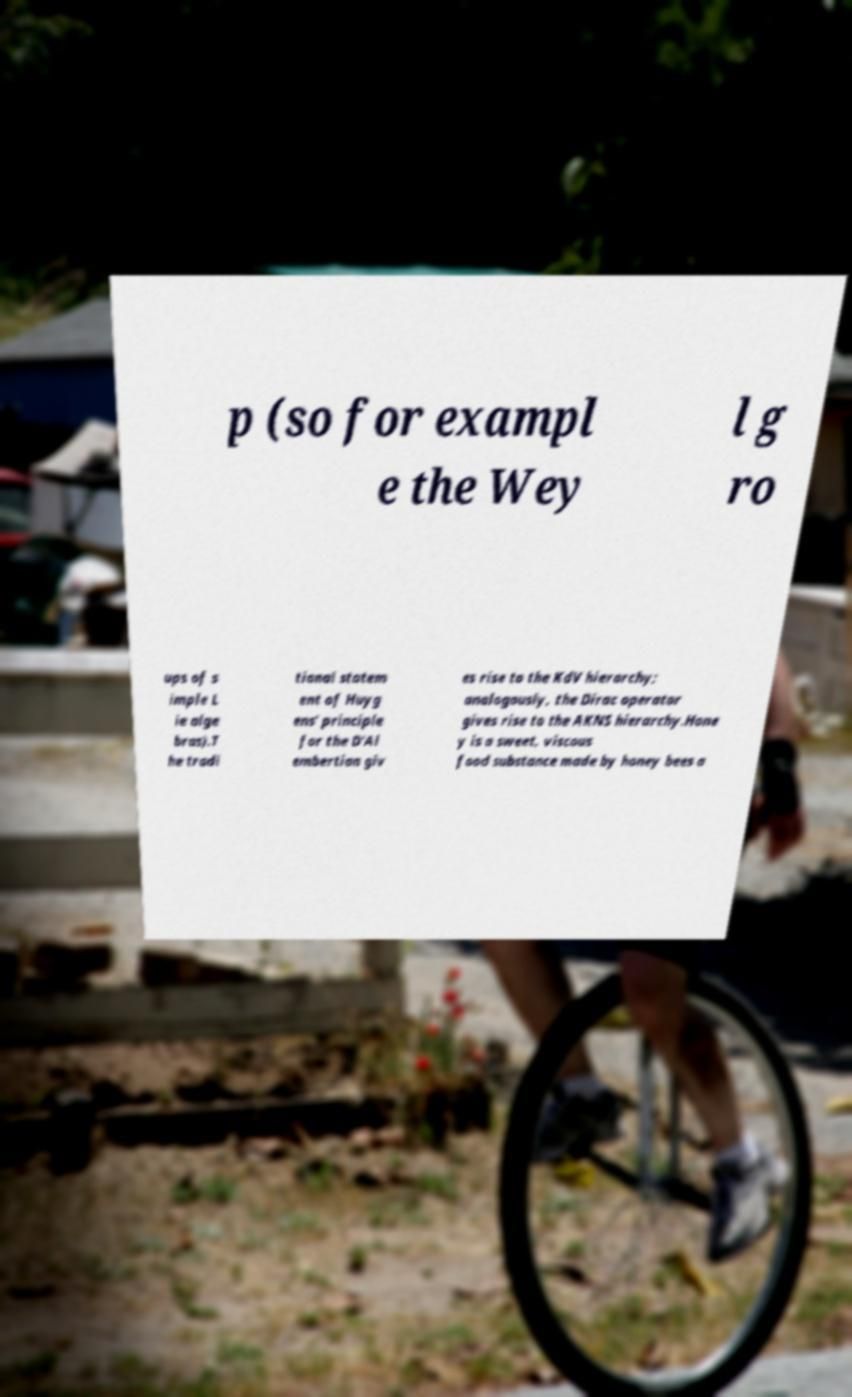Please identify and transcribe the text found in this image. p (so for exampl e the Wey l g ro ups of s imple L ie alge bras).T he tradi tional statem ent of Huyg ens' principle for the D'Al embertian giv es rise to the KdV hierarchy; analogously, the Dirac operator gives rise to the AKNS hierarchy.Hone y is a sweet, viscous food substance made by honey bees a 